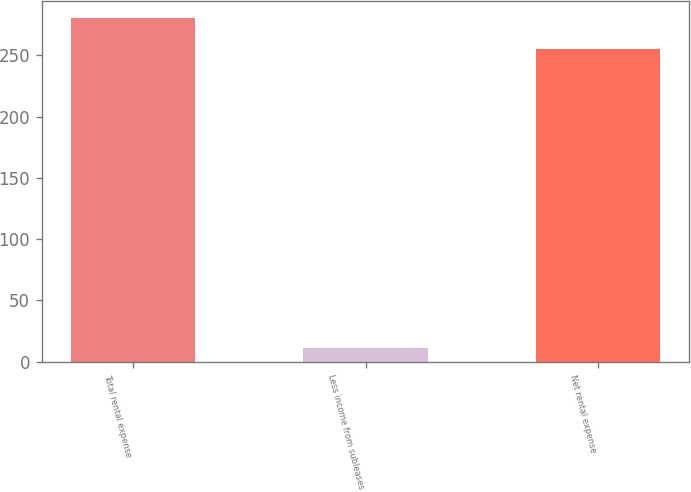Convert chart. <chart><loc_0><loc_0><loc_500><loc_500><bar_chart><fcel>Total rental expense<fcel>Less income from subleases<fcel>Net rental expense<nl><fcel>280.5<fcel>11<fcel>255<nl></chart> 